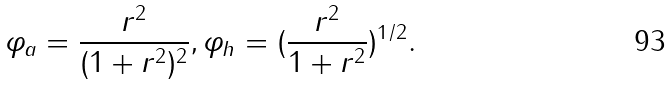Convert formula to latex. <formula><loc_0><loc_0><loc_500><loc_500>\varphi _ { a } = \frac { r ^ { 2 } } { ( 1 + r ^ { 2 } ) ^ { 2 } } , \varphi _ { h } = ( \frac { r ^ { 2 } } { 1 + r ^ { 2 } } ) ^ { 1 / 2 } .</formula> 